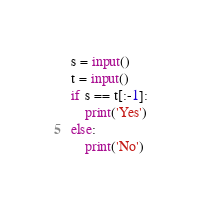<code> <loc_0><loc_0><loc_500><loc_500><_Python_>s = input()
t = input()
if s == t[:-1]:
    print('Yes')
else:
    print('No')
</code> 